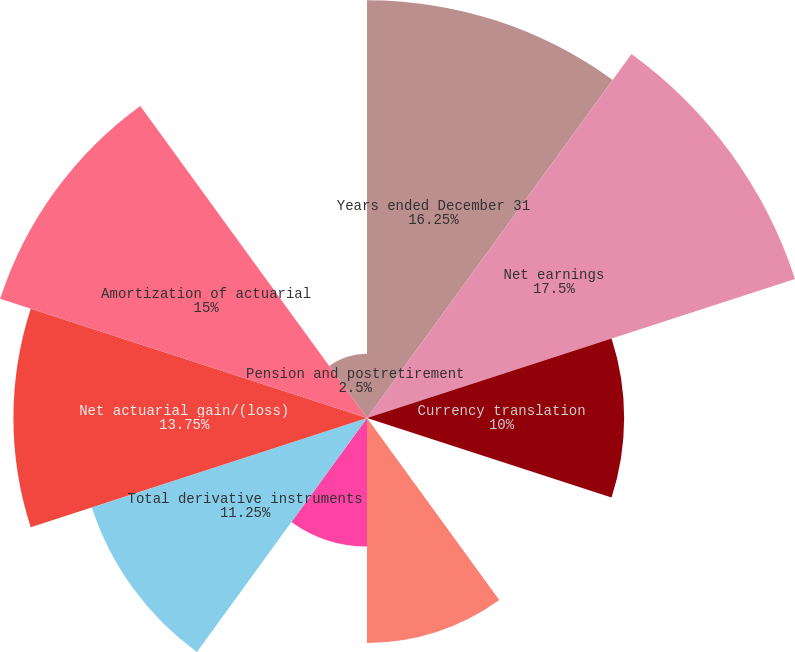<chart> <loc_0><loc_0><loc_500><loc_500><pie_chart><fcel>Years ended December 31<fcel>Net earnings<fcel>Currency translation<fcel>Unrealized gain/(loss) on<fcel>Unrealized (loss)/gain arising<fcel>Reclassification adjustment<fcel>Total derivative instruments<fcel>Net actuarial gain/(loss)<fcel>Amortization of actuarial<fcel>Pension and postretirement<nl><fcel>16.25%<fcel>17.5%<fcel>10.0%<fcel>0.0%<fcel>8.75%<fcel>5.0%<fcel>11.25%<fcel>13.75%<fcel>15.0%<fcel>2.5%<nl></chart> 